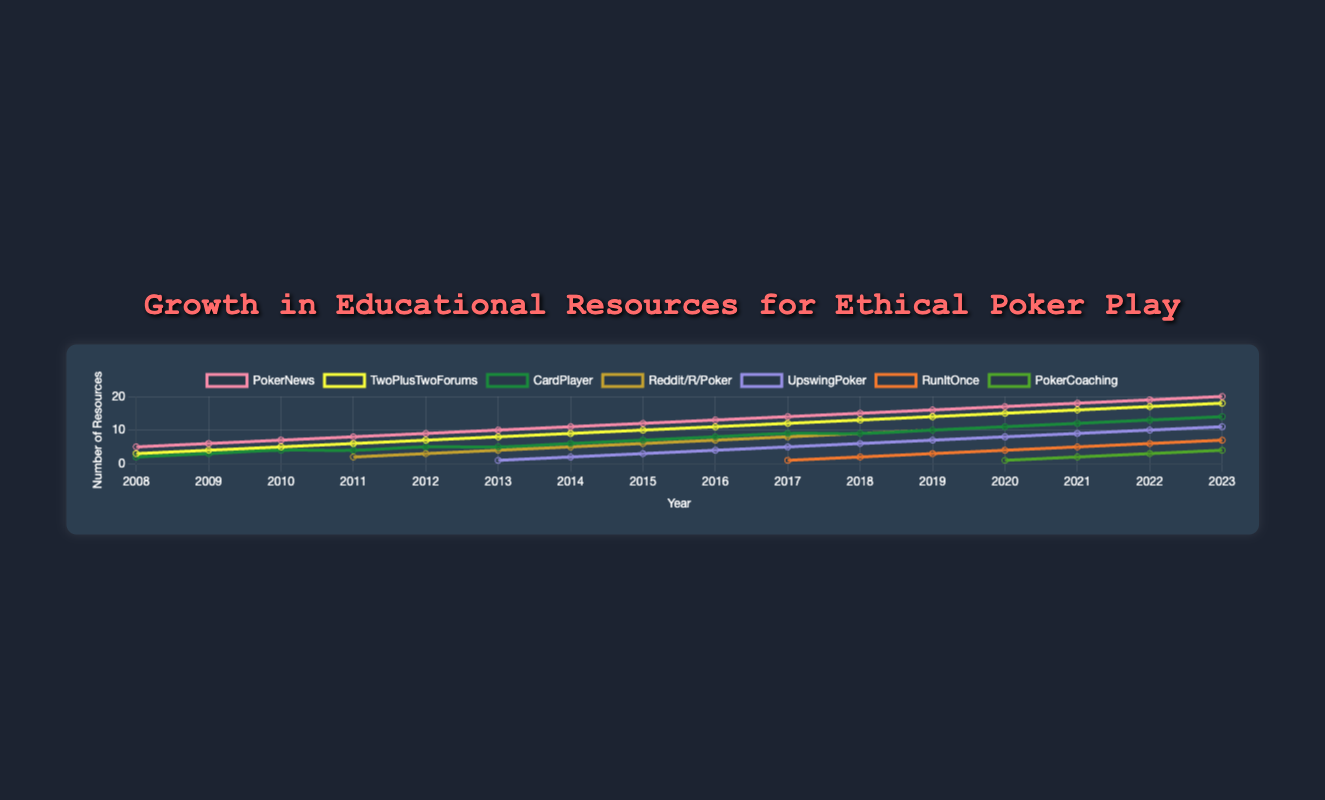Which entity had the most significant growth from 2008 to 2023? By observing the lines on the chart, we note that PokerNews had substantial growth from 2008 with 5 resources to 2023 with 20 resources. This is the largest numeric increase among all entities.
Answer: PokerNews How many resources were available in total in 2015? Summing up the resources for each entity in 2015: PokerNews (12) + TwoPlusTwoForums (10) + CardPlayer (7) + Reddit/R/Poker (6) + UpswingPoker (3) = 38
Answer: 38 Which year saw the introduction of the highest number of new entities? In 2017, three new entities were introduced: Reddit/R/Poker, UpswingPoker, and RunItOnce. This is the highest single-year increment.
Answer: 2017 What is the difference in the number of resources between TwoPlusTwoForums and CardPlayer in 2023? In 2023, TwoPlusTwoForums has 18 resources while CardPlayer has 14. The difference is 18 - 14 = 4
Answer: 4 Between which years did PokerNews experience the highest single-year increase in resources? The largest single-year increase for PokerNews is from 2022 to 2023, where the resources went from 19 to 20, an increase of 1. Observing other years no larger single-year increment can be seen.
Answer: 2022 to 2023 What was the combined total of resources from RunItOnce and Reddit/R/Poker in 2020? In 2020, RunItOnce had 4 resources and Reddit/R/Poker had 11. Combining these gives 4 + 11 = 15
Answer: 15 Which entity had the slowest growth rate over the period 2008 to 2023? By observing the slopes of the lines, CardPlayer had the slowest growth, going from 2 in 2008 to 14 in 2023, which are lower increases compared to other entities.
Answer: CardPlayer What year did Reddit/R/Poker first appear in the chart, and how many resources did it have that year? Reddit/R/Poker appears first in 2011 with 2 resources.
Answer: 2011, 2 What is the average number of resources for UpswingPoker from 2013 to 2023? Summing the resources of UpswingPoker from 2013 (1), 2014 (2), 2015 (3), 2016 (4), 2017 (5), 2018 (6), 2019 (7), 2020 (8), 2021 (9), 2022 (10), 2023 (11) gives 66. There are 11 years, so average = 66/11 = 6
Answer: 6 In which year did PokerCoaching first appear, and how many resources did it have? PokerCoaching made its first appearance in 2020 with 1 resource.
Answer: 2020, 1 